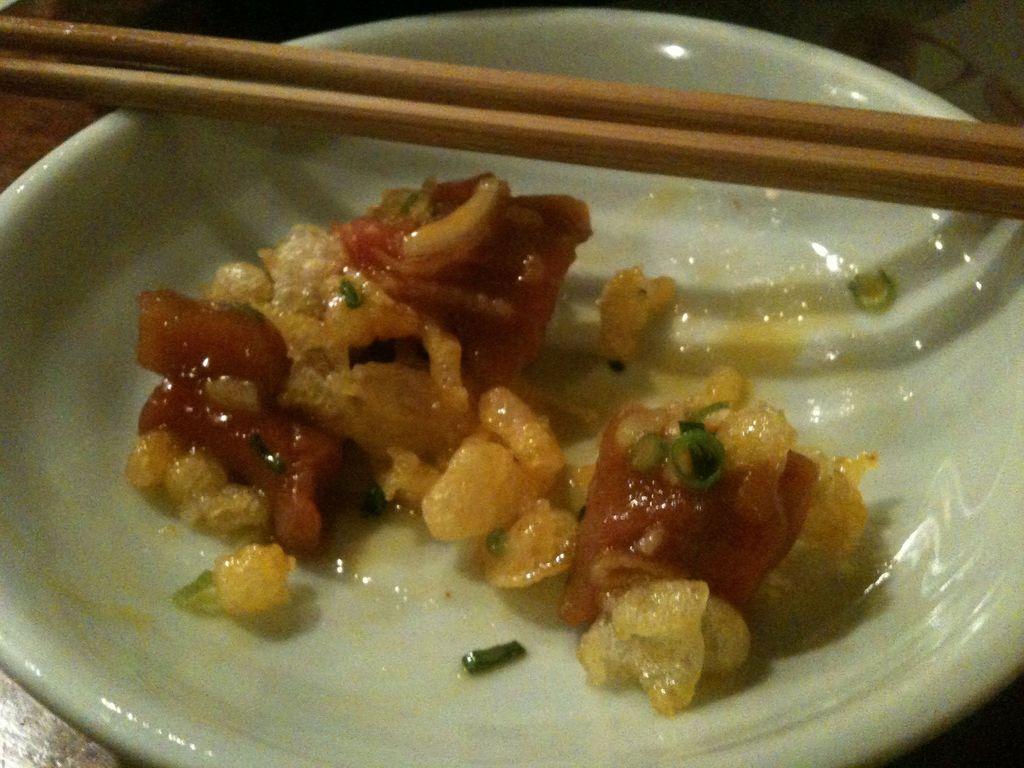Describe this image in one or two sentences. In this image we can see wooden chopsticks and plate with food placed on the table. 